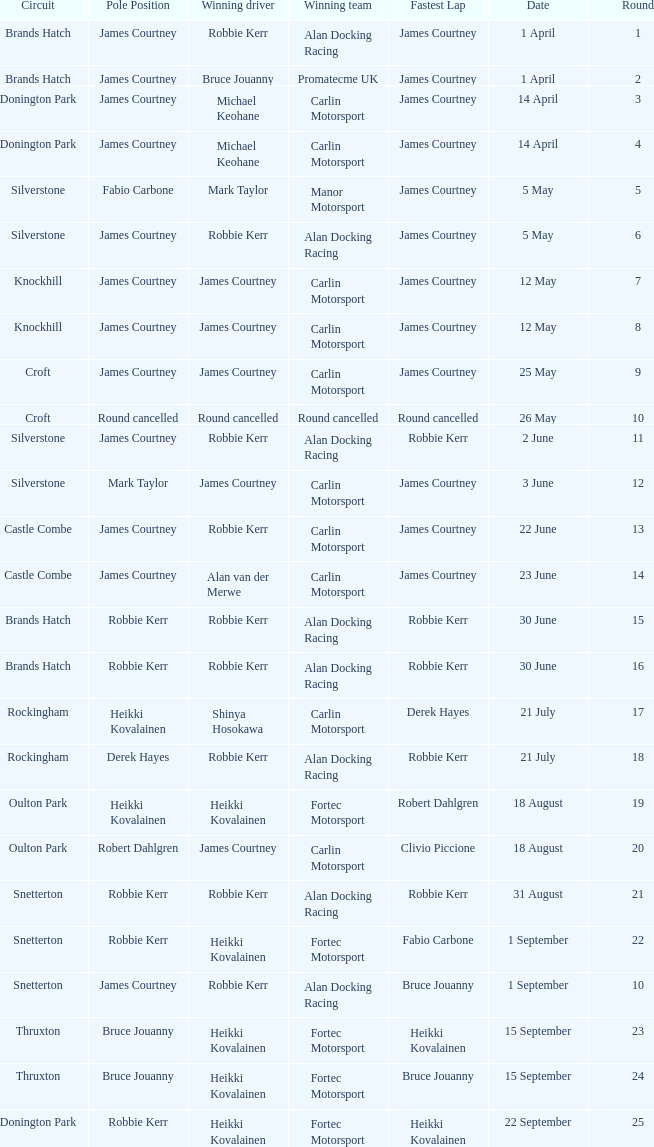What is every date of Mark Taylor as winning driver? 5 May. 